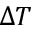<formula> <loc_0><loc_0><loc_500><loc_500>\Delta T</formula> 